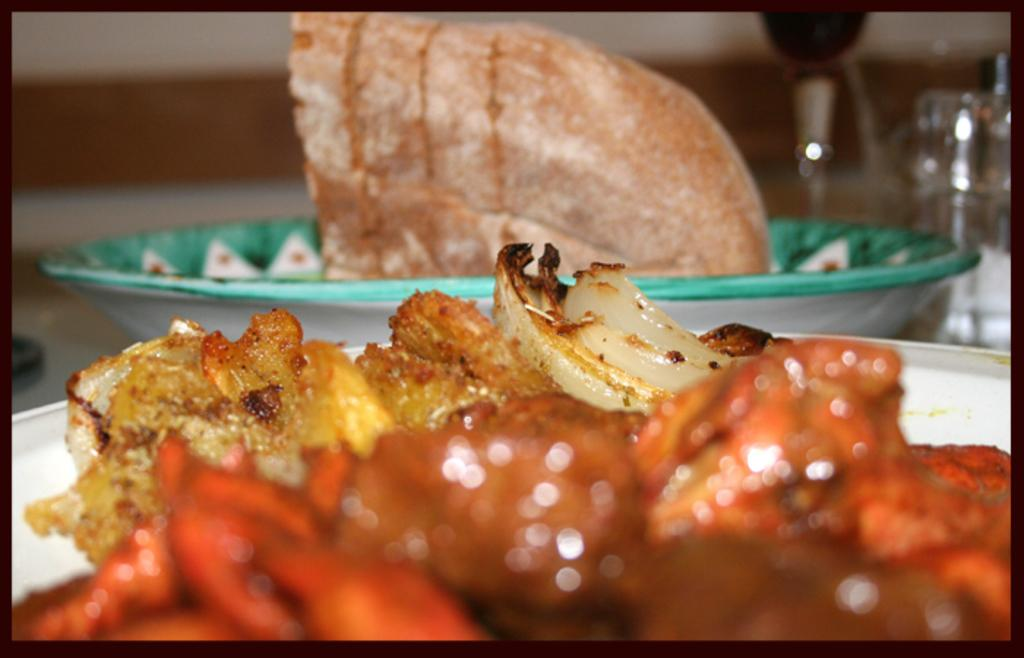What is present on the plates in the image? There is food in the plates. Can you describe the background of the image? The background of the image is blurry. What type of pie is being served on the plates in the image? There is no pie present in the image; only food in the plates is mentioned. Can you see a monkey in the image? There is no monkey present in the image. 